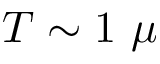<formula> <loc_0><loc_0><loc_500><loc_500>T \sim 1 \ \mu</formula> 